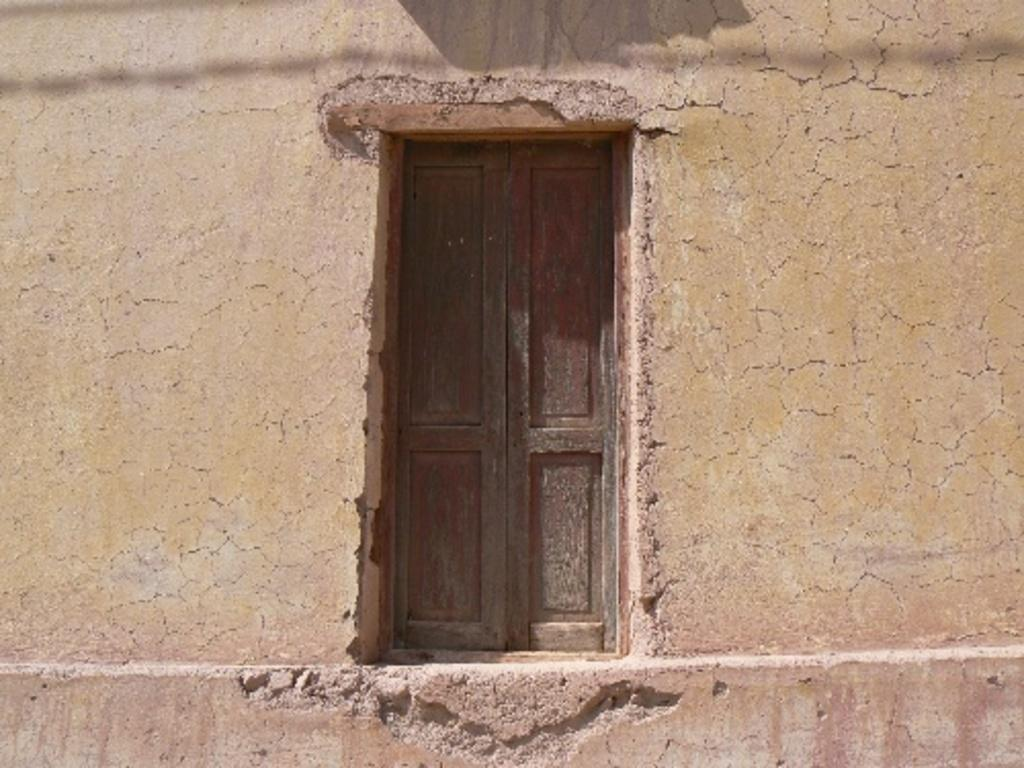What type of structure is visible in the image? There is a house in the image. What feature can be seen at the front of the house? There is a door in the front of the house. What else is present at the front of the house? There is a wall in the front of the house. What type of toys are advertised on the wall of the house in the image? There are no toys or advertisements present on the wall of the house in the image. 